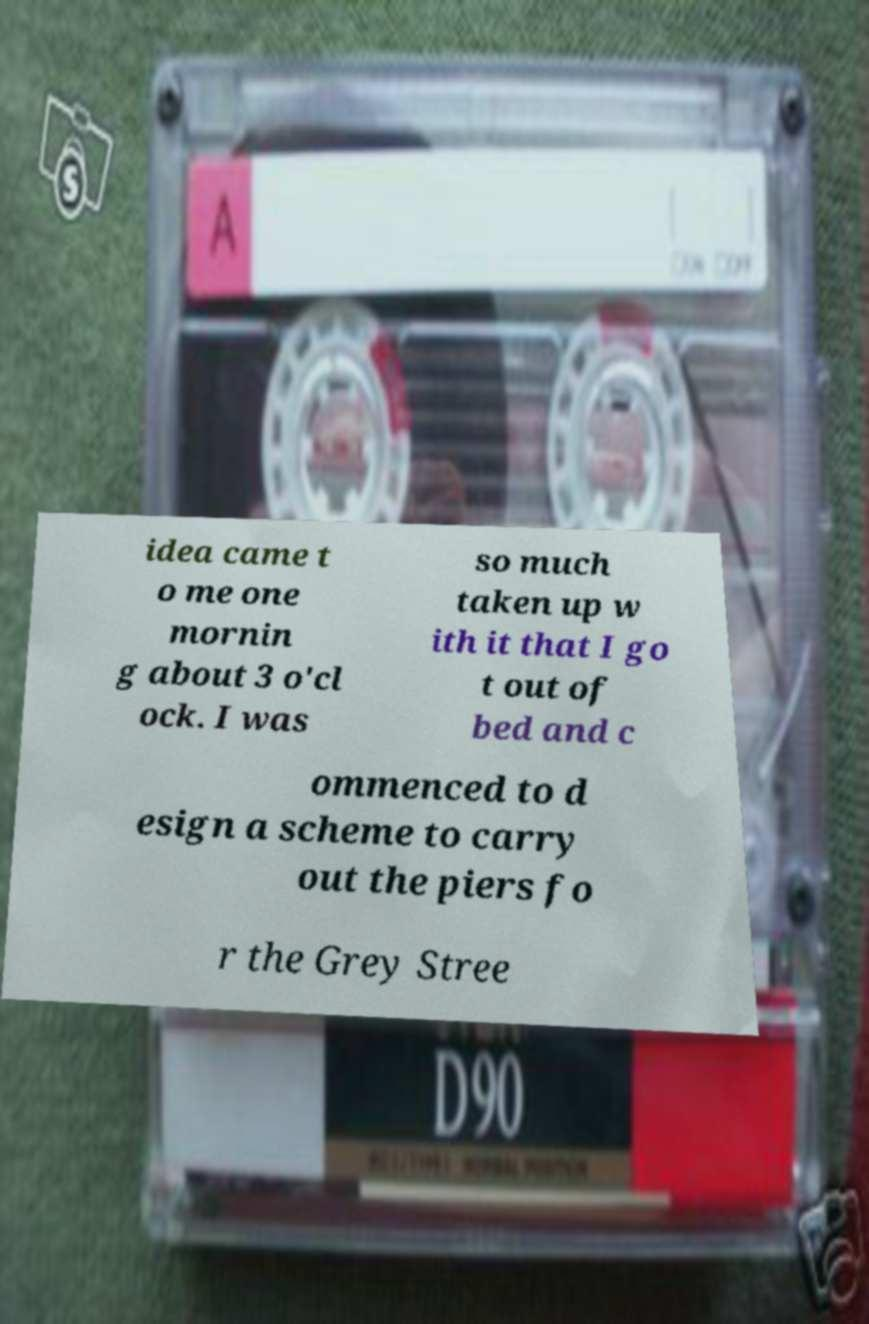For documentation purposes, I need the text within this image transcribed. Could you provide that? idea came t o me one mornin g about 3 o'cl ock. I was so much taken up w ith it that I go t out of bed and c ommenced to d esign a scheme to carry out the piers fo r the Grey Stree 